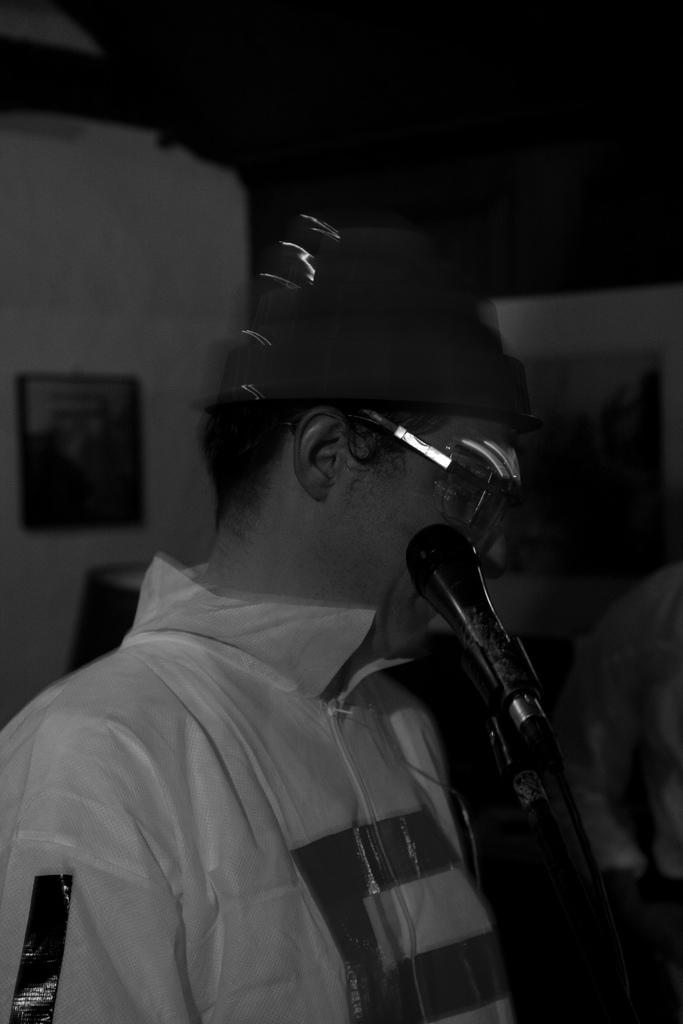Can you describe this image briefly? In this image I can see a person standing. There is a microphone in front of him. There is a photo frame at the back. This is a black and white image. 